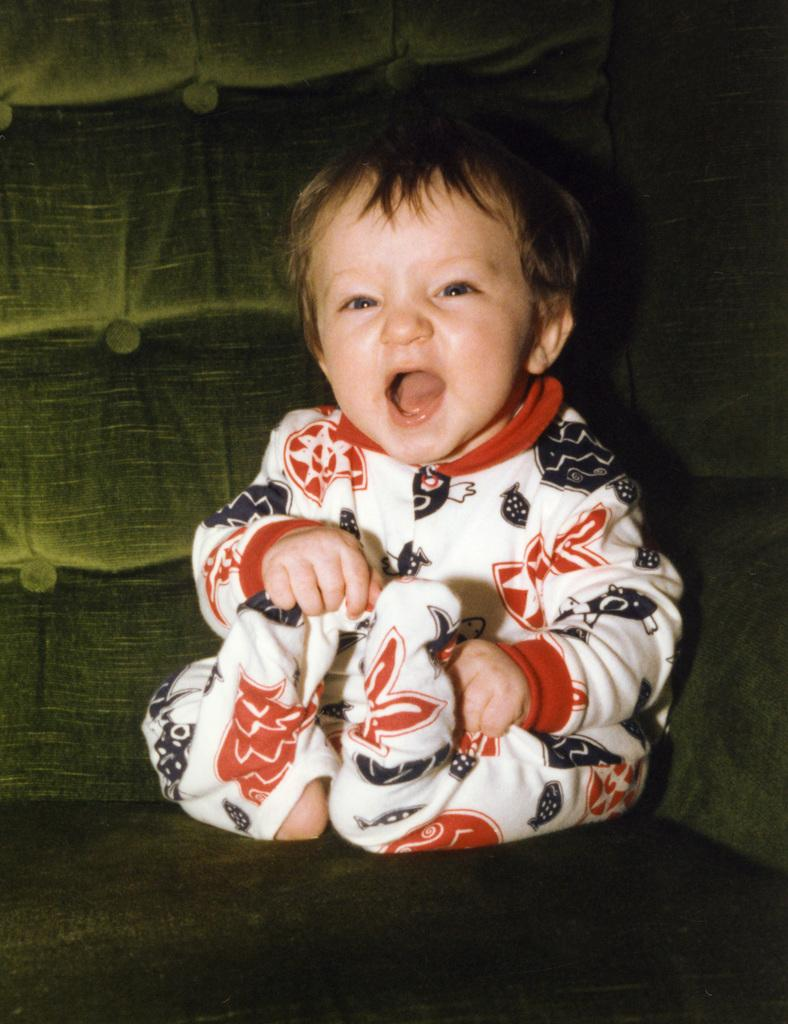What is the main subject of the image? The main subject of the image is a kid. Where is the kid located in the image? The kid is on a sofa in the image. How is the kid positioned in the image? The kid is in the center of the image. What type of payment is the kid making in the image? There is no payment being made in the image; it simply shows a kid on a sofa. What memories does the kid have while sitting on the sofa? The image does not provide any information about the kid's memories, so we cannot determine what they might be thinking or remembering. 